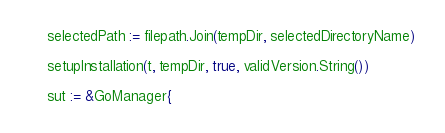<code> <loc_0><loc_0><loc_500><loc_500><_Go_>	selectedPath := filepath.Join(tempDir, selectedDirectoryName)

	setupInstallation(t, tempDir, true, validVersion.String())

	sut := &GoManager{</code> 